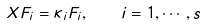<formula> <loc_0><loc_0><loc_500><loc_500>X F _ { i } = \kappa _ { i } F _ { i } , \quad i = 1 , \cdots , s</formula> 